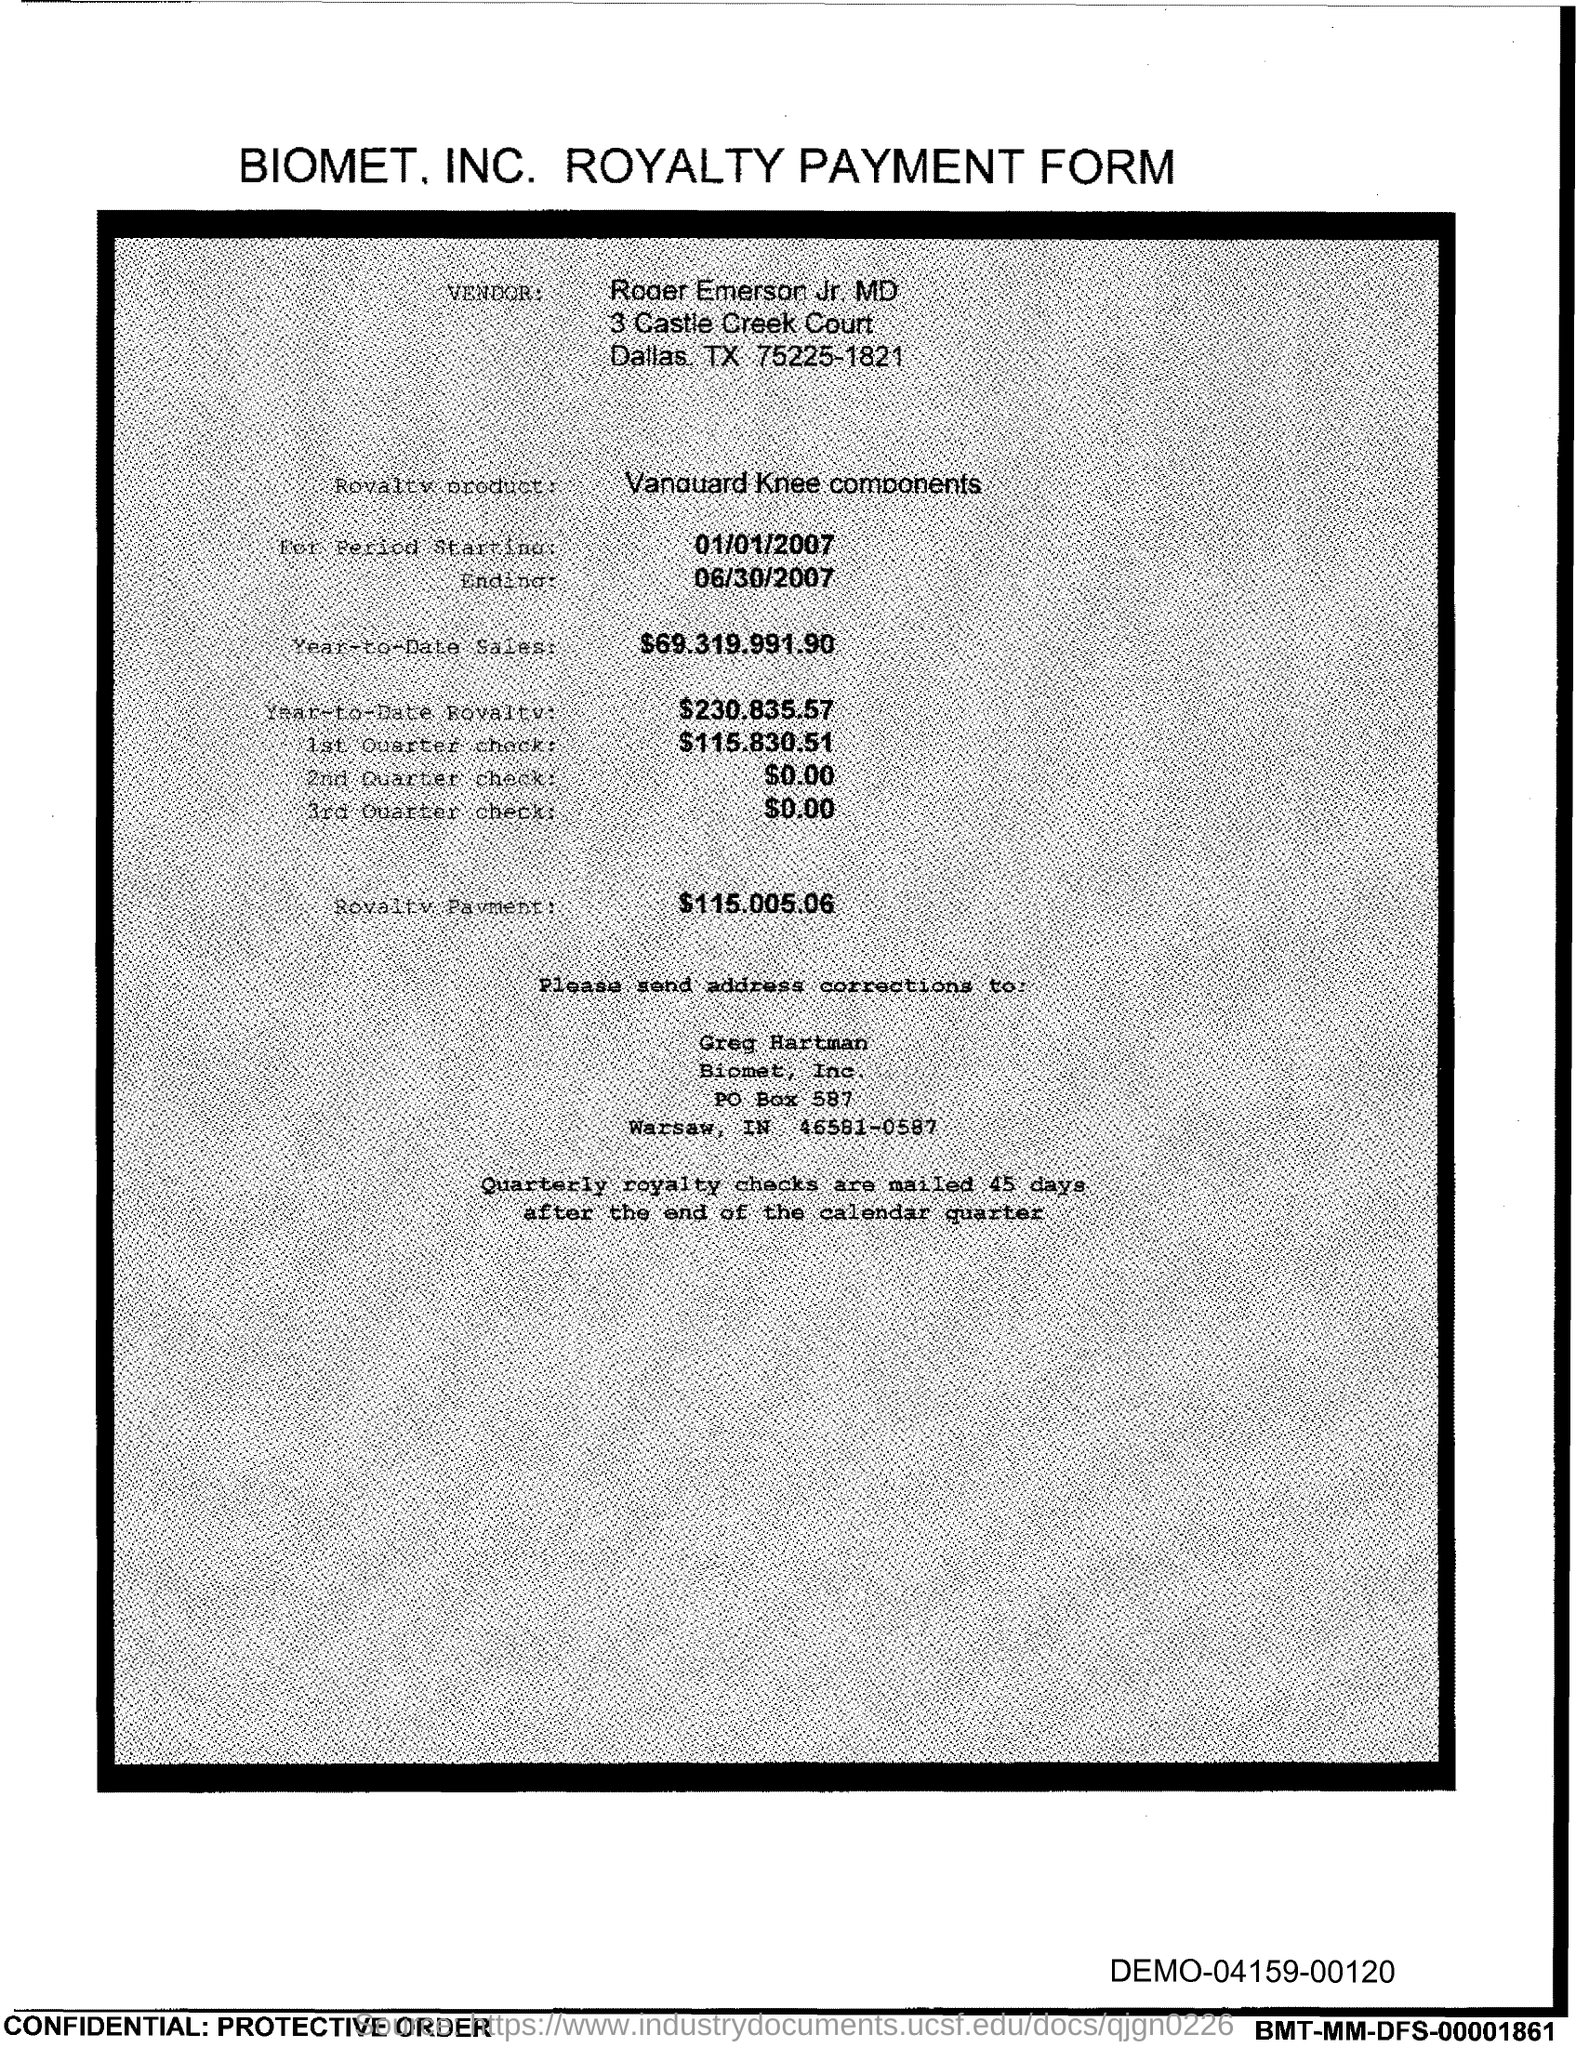What is the PO Box Number mentioned in the document?
Your answer should be compact. 587. 